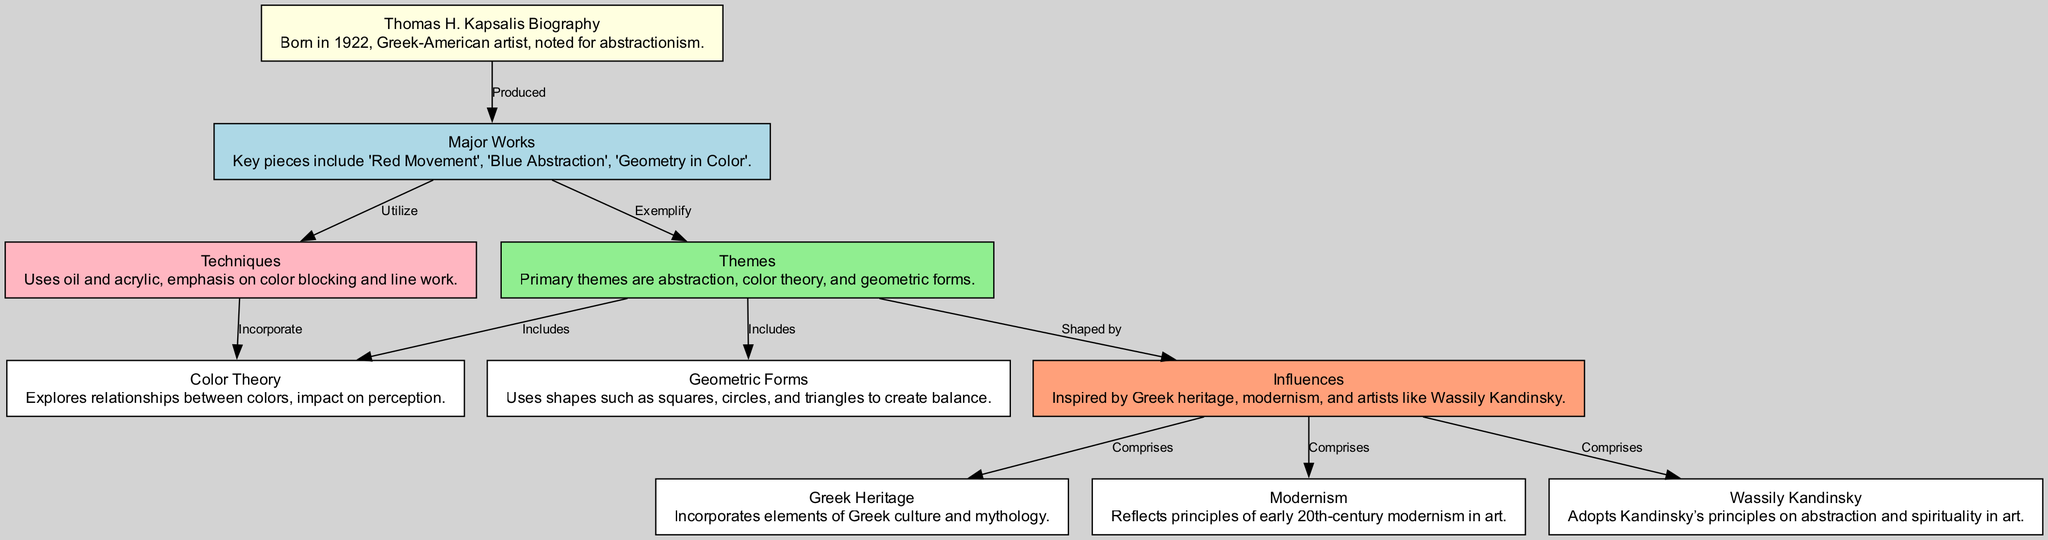What is the birth year of Thomas H. Kapsalis? The diagram states that Thomas H. Kapsalis was born in 1922, which is located in the biography node labeled "Thomas H. Kapsalis Biography."
Answer: 1922 How many major works are listed in the diagram? The diagram shows three major works listed under the "Major Works" node, which are 'Red Movement', 'Blue Abstraction', and 'Geometry in Color'.
Answer: 3 Which themes are included under "Themes"? The "Themes" node lists three main themes: abstraction, color theory, and geometric forms. These are directly mentioned as part of the node details.
Answer: abstraction, color theory, geometric forms What primary influence does Kapsalis draw from his cultural background? The "Influences" node indicates that Greek heritage is one of the main components that comprise Kapsalis's influences, which is connected from the influences node to Greek heritage.
Answer: Greek heritage Which major work exemplifies the theme of color theory? The "Major Works" node leads to the "Themes" node, which connects to "Color Theory". Therefore, it follows that "Red Movement," for instance, could exemplify this theme, but the specific work isn't directly stated in the connection.
Answer: Cannot be determined directly How are the shapes utilized in Kapsalis's work categorized? The node labeled "Geometric Forms" outlines that Kapsalis uses shapes such as squares, circles, and triangles, which contribute to the themes of balance expressed in the diagram.
Answer: Squares, circles, triangles What artistic principle does Kapsalis adopt from Wassily Kandinsky? The diagram illustrates a direct connection from the "KandinskyInfluence" node to "Influences," stating that Kapsalis adopts Kandinsky’s principles on abstraction and spirituality in art.
Answer: Abstraction and spirituality Which technique is emphasized in Kapsalis’s major works? The "Techniques" node denotes an emphasis on color blocking and line work, indicating the specific artistic methods used in Kapsalis's works.
Answer: Color blocking and line work 